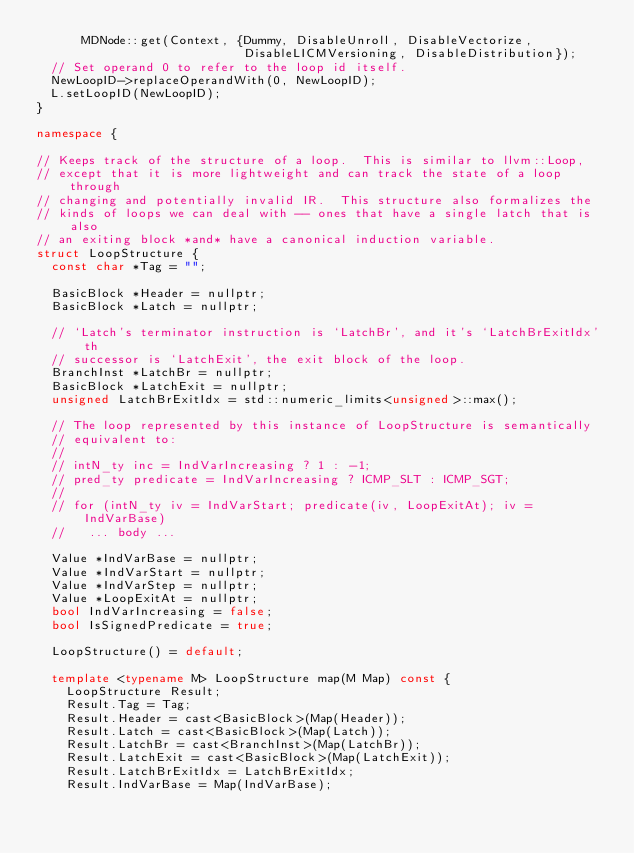Convert code to text. <code><loc_0><loc_0><loc_500><loc_500><_C++_>      MDNode::get(Context, {Dummy, DisableUnroll, DisableVectorize,
                            DisableLICMVersioning, DisableDistribution});
  // Set operand 0 to refer to the loop id itself.
  NewLoopID->replaceOperandWith(0, NewLoopID);
  L.setLoopID(NewLoopID);
}

namespace {

// Keeps track of the structure of a loop.  This is similar to llvm::Loop,
// except that it is more lightweight and can track the state of a loop through
// changing and potentially invalid IR.  This structure also formalizes the
// kinds of loops we can deal with -- ones that have a single latch that is also
// an exiting block *and* have a canonical induction variable.
struct LoopStructure {
  const char *Tag = "";

  BasicBlock *Header = nullptr;
  BasicBlock *Latch = nullptr;

  // `Latch's terminator instruction is `LatchBr', and it's `LatchBrExitIdx'th
  // successor is `LatchExit', the exit block of the loop.
  BranchInst *LatchBr = nullptr;
  BasicBlock *LatchExit = nullptr;
  unsigned LatchBrExitIdx = std::numeric_limits<unsigned>::max();

  // The loop represented by this instance of LoopStructure is semantically
  // equivalent to:
  //
  // intN_ty inc = IndVarIncreasing ? 1 : -1;
  // pred_ty predicate = IndVarIncreasing ? ICMP_SLT : ICMP_SGT;
  //
  // for (intN_ty iv = IndVarStart; predicate(iv, LoopExitAt); iv = IndVarBase)
  //   ... body ...

  Value *IndVarBase = nullptr;
  Value *IndVarStart = nullptr;
  Value *IndVarStep = nullptr;
  Value *LoopExitAt = nullptr;
  bool IndVarIncreasing = false;
  bool IsSignedPredicate = true;

  LoopStructure() = default;

  template <typename M> LoopStructure map(M Map) const {
    LoopStructure Result;
    Result.Tag = Tag;
    Result.Header = cast<BasicBlock>(Map(Header));
    Result.Latch = cast<BasicBlock>(Map(Latch));
    Result.LatchBr = cast<BranchInst>(Map(LatchBr));
    Result.LatchExit = cast<BasicBlock>(Map(LatchExit));
    Result.LatchBrExitIdx = LatchBrExitIdx;
    Result.IndVarBase = Map(IndVarBase);</code> 